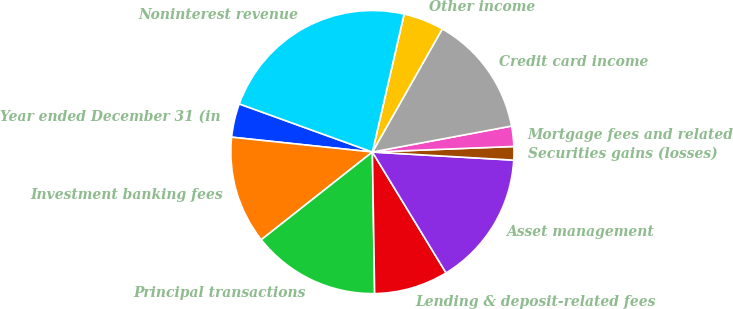Convert chart. <chart><loc_0><loc_0><loc_500><loc_500><pie_chart><fcel>Year ended December 31 (in<fcel>Investment banking fees<fcel>Principal transactions<fcel>Lending & deposit-related fees<fcel>Asset management<fcel>Securities gains (losses)<fcel>Mortgage fees and related<fcel>Credit card income<fcel>Other income<fcel>Noninterest revenue<nl><fcel>3.85%<fcel>12.31%<fcel>14.62%<fcel>8.46%<fcel>15.38%<fcel>1.54%<fcel>2.31%<fcel>13.85%<fcel>4.62%<fcel>23.08%<nl></chart> 